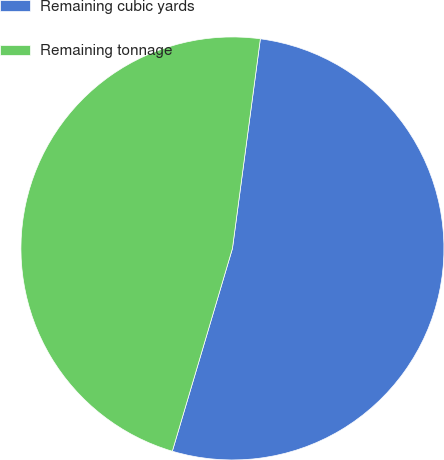Convert chart to OTSL. <chart><loc_0><loc_0><loc_500><loc_500><pie_chart><fcel>Remaining cubic yards<fcel>Remaining tonnage<nl><fcel>52.48%<fcel>47.52%<nl></chart> 